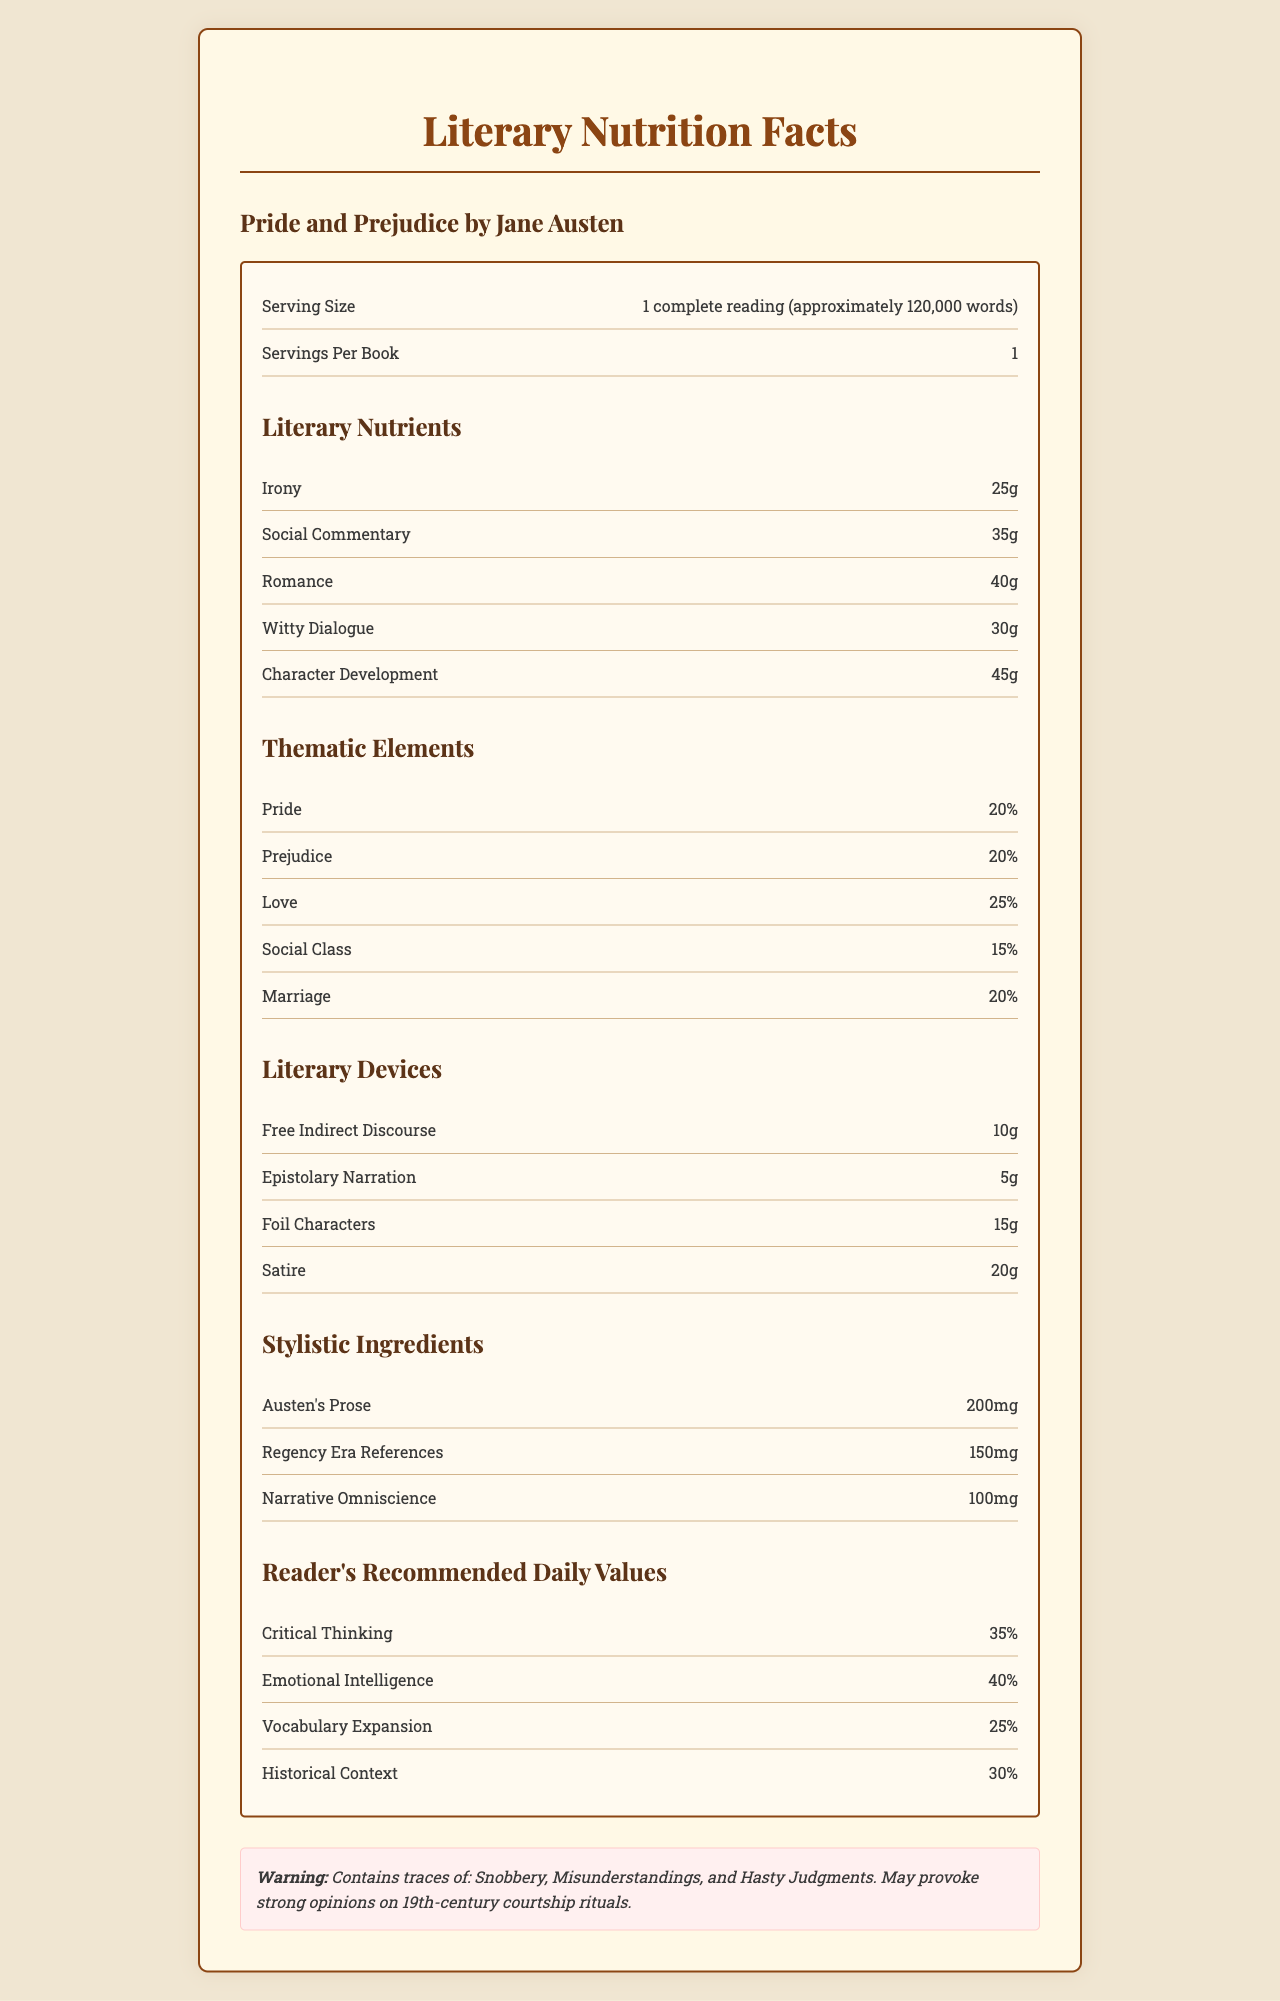what is the novel title mentioned in the document? The document clearly states the novel title in the heading and in the content sections.
Answer: Pride and Prejudice by Jane Austen what is the serving size for this literary work? The serving size is directly mentioned in the document.
Answer: 1 complete reading (approximately 120,000 words) how many servings are there per book? The document states there is 1 serving per book.
Answer: 1 name two literary nutrients mentioned in the document. Irony and Social Commentary are listed under Literary Nutrients.
Answer: Irony, Social Commentary what are the thematic elements covered in this novel? These thematic elements are listed in a dedicated section labeled 'Thematic Elements'.
Answer: Pride, Prejudice, Love, Social Class, Marriage which thematic element has the highest percentage? A. Pride B. Prejudice C. Love D. Social Class The percentage for each thematic element is listed, and Love has the highest at 25%.
Answer: C. Love how much Witty Dialogue is in the novel? A. 20g B. 25g C. 30g D. 35g Witty Dialogue is listed under Literary Nutrients as 30g.
Answer: C. 30g does the novel include any narrative technique called Free Indirect Discourse? Free Indirect Discourse is listed among the Literary Devices in the document.
Answer: Yes write a brief summary of this document. The summary includes information on serving size, number of servings, various literary nutrients, thematic elements, literary devices, and warnings for readers.
Answer: The document presents a detailed "Nutrition Facts Label" for Jane Austen's "Pride and Prejudice," detailing its literary and thematic elements, literary devices, and stylistic ingredients. It also includes recommended values for readers' intellectual development. what impact do Austen's prose and Regency Era References have according to the document? These are listed under Stylistic Ingredients with specific quantities mentioned.
Answer: Austen's Prose: 200mg, Regency Era References: 150mg why might someone find this document insightful? The document provides a novel way to look at a classic literary work which appeals to both literature enthusiasts and those interested in detailed analysis.
Answer: It breaks down the literary components of "Pride and Prejudice" in a unique format, making it easier to analyze the novel's themes and stylistic elements. how much Character Development is listed in the document? The amount of Character Development is provided under Literary Nutrients.
Answer: 45g is the percentage of Prejudice higher than that of Social Class in the thematic elements? Prejudice is listed at 20% while Social Class is at 15%.
Answer: Yes can the narrative importance of Misunderstandings be determined from the document? The document only mentions Misunderstandings in the warning section, without detailing their narrative role.
Answer: Not enough information 